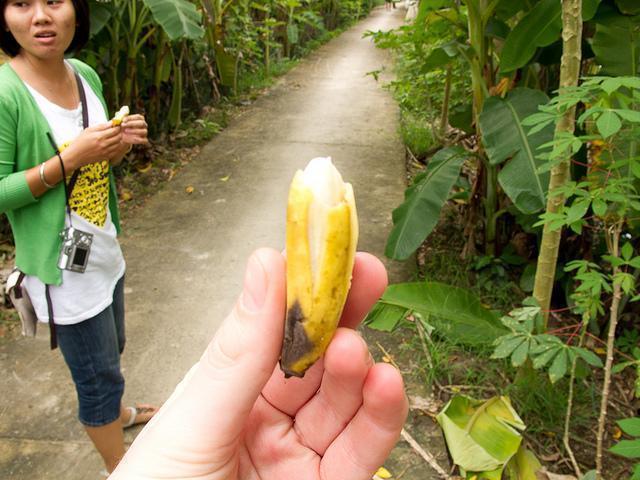The woman eating the fruit is likely on the path for what reason?
Make your selection and explain in format: 'Answer: answer
Rationale: rationale.'
Options: Surveying, tourism, assisting, commuting. Answer: tourism.
Rationale: She has a camera dangling from her wrist. 